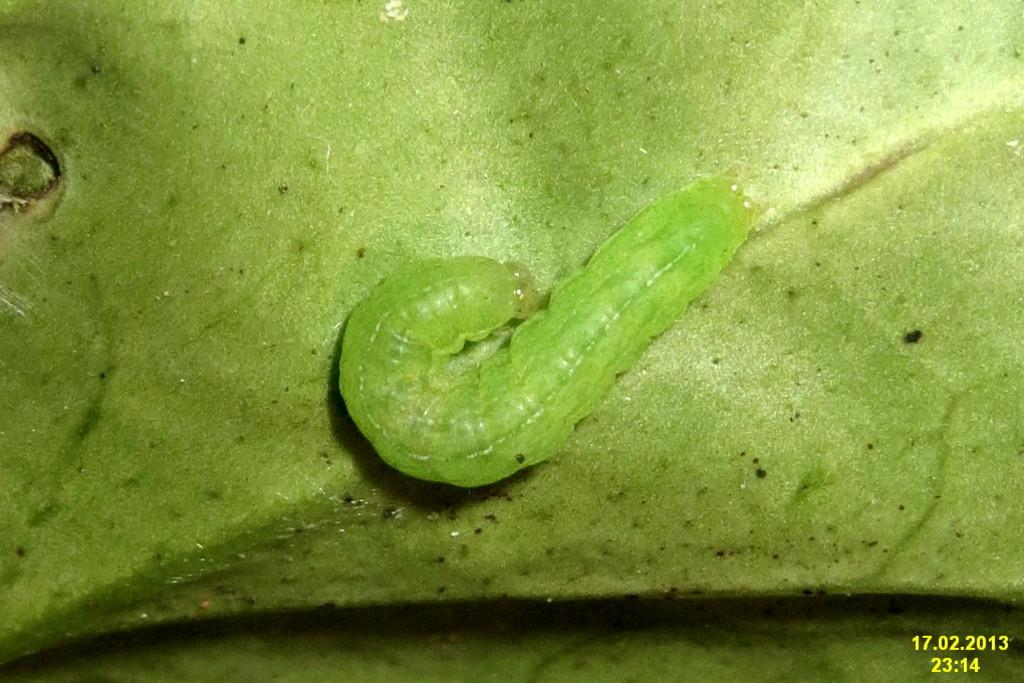What is the main subject of the image? The main subject of the image is a caterpillar. Where is the caterpillar located in the image? The caterpillar is on a leaf in the image. What type of vest is the caterpillar wearing in the image? The caterpillar is not wearing a vest in the image; it is a living creature and does not wear clothing. 